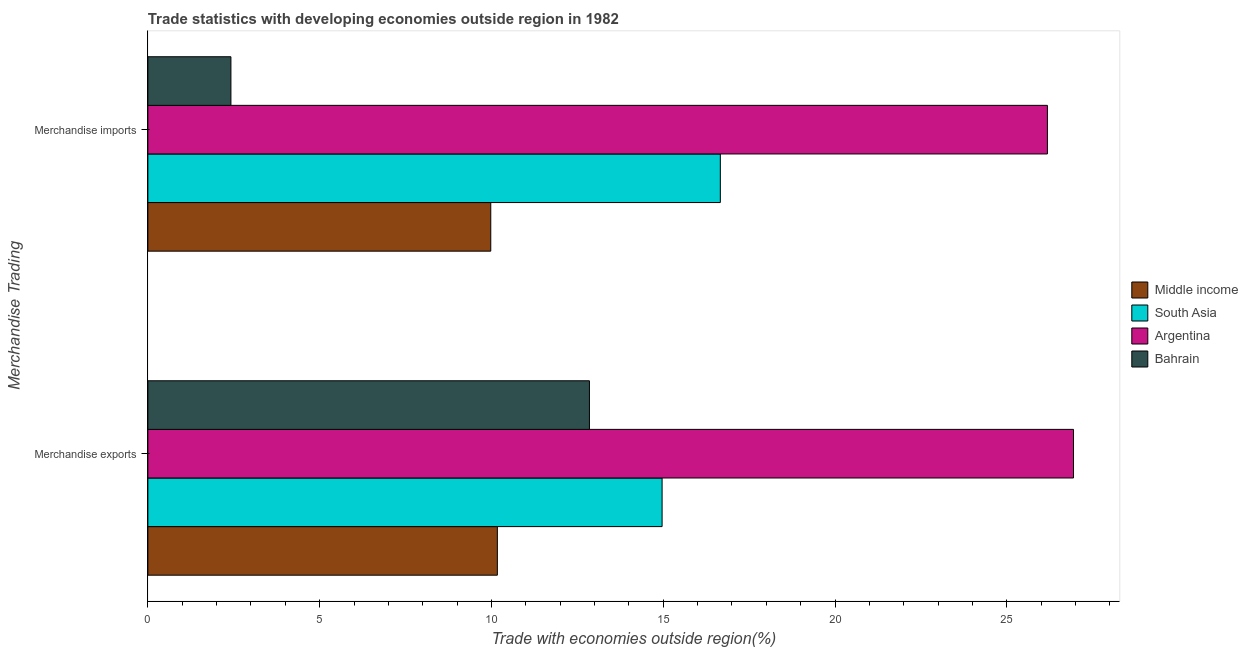How many different coloured bars are there?
Provide a short and direct response. 4. Are the number of bars per tick equal to the number of legend labels?
Your response must be concise. Yes. Are the number of bars on each tick of the Y-axis equal?
Offer a very short reply. Yes. How many bars are there on the 2nd tick from the top?
Provide a short and direct response. 4. What is the label of the 1st group of bars from the top?
Your answer should be compact. Merchandise imports. What is the merchandise exports in Bahrain?
Keep it short and to the point. 12.85. Across all countries, what is the maximum merchandise exports?
Provide a short and direct response. 26.94. Across all countries, what is the minimum merchandise imports?
Provide a succinct answer. 2.42. In which country was the merchandise imports minimum?
Your response must be concise. Bahrain. What is the total merchandise imports in the graph?
Offer a very short reply. 55.24. What is the difference between the merchandise imports in Bahrain and that in South Asia?
Your answer should be very brief. -14.24. What is the difference between the merchandise imports in Argentina and the merchandise exports in South Asia?
Keep it short and to the point. 11.22. What is the average merchandise exports per country?
Make the answer very short. 16.23. What is the difference between the merchandise imports and merchandise exports in Argentina?
Offer a very short reply. -0.76. What is the ratio of the merchandise imports in Argentina to that in Middle income?
Give a very brief answer. 2.62. Is the merchandise imports in Middle income less than that in Bahrain?
Keep it short and to the point. No. In how many countries, is the merchandise exports greater than the average merchandise exports taken over all countries?
Ensure brevity in your answer.  1. How many bars are there?
Your answer should be compact. 8. Are all the bars in the graph horizontal?
Give a very brief answer. Yes. How many countries are there in the graph?
Offer a terse response. 4. What is the difference between two consecutive major ticks on the X-axis?
Ensure brevity in your answer.  5. Does the graph contain any zero values?
Make the answer very short. No. Does the graph contain grids?
Offer a terse response. No. Where does the legend appear in the graph?
Your answer should be compact. Center right. How are the legend labels stacked?
Your answer should be very brief. Vertical. What is the title of the graph?
Offer a terse response. Trade statistics with developing economies outside region in 1982. Does "Mali" appear as one of the legend labels in the graph?
Offer a very short reply. No. What is the label or title of the X-axis?
Give a very brief answer. Trade with economies outside region(%). What is the label or title of the Y-axis?
Your response must be concise. Merchandise Trading. What is the Trade with economies outside region(%) of Middle income in Merchandise exports?
Provide a short and direct response. 10.17. What is the Trade with economies outside region(%) of South Asia in Merchandise exports?
Your answer should be very brief. 14.97. What is the Trade with economies outside region(%) of Argentina in Merchandise exports?
Give a very brief answer. 26.94. What is the Trade with economies outside region(%) in Bahrain in Merchandise exports?
Offer a terse response. 12.85. What is the Trade with economies outside region(%) in Middle income in Merchandise imports?
Provide a succinct answer. 9.98. What is the Trade with economies outside region(%) of South Asia in Merchandise imports?
Offer a terse response. 16.66. What is the Trade with economies outside region(%) in Argentina in Merchandise imports?
Provide a short and direct response. 26.18. What is the Trade with economies outside region(%) of Bahrain in Merchandise imports?
Your answer should be compact. 2.42. Across all Merchandise Trading, what is the maximum Trade with economies outside region(%) of Middle income?
Make the answer very short. 10.17. Across all Merchandise Trading, what is the maximum Trade with economies outside region(%) of South Asia?
Your response must be concise. 16.66. Across all Merchandise Trading, what is the maximum Trade with economies outside region(%) in Argentina?
Your answer should be compact. 26.94. Across all Merchandise Trading, what is the maximum Trade with economies outside region(%) of Bahrain?
Give a very brief answer. 12.85. Across all Merchandise Trading, what is the minimum Trade with economies outside region(%) in Middle income?
Ensure brevity in your answer.  9.98. Across all Merchandise Trading, what is the minimum Trade with economies outside region(%) of South Asia?
Your response must be concise. 14.97. Across all Merchandise Trading, what is the minimum Trade with economies outside region(%) of Argentina?
Offer a very short reply. 26.18. Across all Merchandise Trading, what is the minimum Trade with economies outside region(%) of Bahrain?
Your answer should be very brief. 2.42. What is the total Trade with economies outside region(%) in Middle income in the graph?
Offer a terse response. 20.15. What is the total Trade with economies outside region(%) in South Asia in the graph?
Provide a succinct answer. 31.63. What is the total Trade with economies outside region(%) of Argentina in the graph?
Your answer should be very brief. 53.12. What is the total Trade with economies outside region(%) of Bahrain in the graph?
Offer a terse response. 15.27. What is the difference between the Trade with economies outside region(%) of Middle income in Merchandise exports and that in Merchandise imports?
Give a very brief answer. 0.19. What is the difference between the Trade with economies outside region(%) in South Asia in Merchandise exports and that in Merchandise imports?
Ensure brevity in your answer.  -1.69. What is the difference between the Trade with economies outside region(%) in Argentina in Merchandise exports and that in Merchandise imports?
Give a very brief answer. 0.76. What is the difference between the Trade with economies outside region(%) of Bahrain in Merchandise exports and that in Merchandise imports?
Offer a very short reply. 10.43. What is the difference between the Trade with economies outside region(%) of Middle income in Merchandise exports and the Trade with economies outside region(%) of South Asia in Merchandise imports?
Offer a very short reply. -6.49. What is the difference between the Trade with economies outside region(%) in Middle income in Merchandise exports and the Trade with economies outside region(%) in Argentina in Merchandise imports?
Your response must be concise. -16.01. What is the difference between the Trade with economies outside region(%) in Middle income in Merchandise exports and the Trade with economies outside region(%) in Bahrain in Merchandise imports?
Your answer should be very brief. 7.75. What is the difference between the Trade with economies outside region(%) in South Asia in Merchandise exports and the Trade with economies outside region(%) in Argentina in Merchandise imports?
Offer a very short reply. -11.22. What is the difference between the Trade with economies outside region(%) in South Asia in Merchandise exports and the Trade with economies outside region(%) in Bahrain in Merchandise imports?
Your response must be concise. 12.55. What is the difference between the Trade with economies outside region(%) in Argentina in Merchandise exports and the Trade with economies outside region(%) in Bahrain in Merchandise imports?
Keep it short and to the point. 24.52. What is the average Trade with economies outside region(%) in Middle income per Merchandise Trading?
Your answer should be compact. 10.08. What is the average Trade with economies outside region(%) in South Asia per Merchandise Trading?
Offer a terse response. 15.81. What is the average Trade with economies outside region(%) in Argentina per Merchandise Trading?
Ensure brevity in your answer.  26.56. What is the average Trade with economies outside region(%) in Bahrain per Merchandise Trading?
Keep it short and to the point. 7.63. What is the difference between the Trade with economies outside region(%) of Middle income and Trade with economies outside region(%) of South Asia in Merchandise exports?
Offer a terse response. -4.8. What is the difference between the Trade with economies outside region(%) of Middle income and Trade with economies outside region(%) of Argentina in Merchandise exports?
Make the answer very short. -16.77. What is the difference between the Trade with economies outside region(%) in Middle income and Trade with economies outside region(%) in Bahrain in Merchandise exports?
Your response must be concise. -2.68. What is the difference between the Trade with economies outside region(%) of South Asia and Trade with economies outside region(%) of Argentina in Merchandise exports?
Provide a succinct answer. -11.97. What is the difference between the Trade with economies outside region(%) in South Asia and Trade with economies outside region(%) in Bahrain in Merchandise exports?
Provide a short and direct response. 2.12. What is the difference between the Trade with economies outside region(%) in Argentina and Trade with economies outside region(%) in Bahrain in Merchandise exports?
Keep it short and to the point. 14.09. What is the difference between the Trade with economies outside region(%) in Middle income and Trade with economies outside region(%) in South Asia in Merchandise imports?
Offer a very short reply. -6.68. What is the difference between the Trade with economies outside region(%) of Middle income and Trade with economies outside region(%) of Argentina in Merchandise imports?
Your response must be concise. -16.2. What is the difference between the Trade with economies outside region(%) in Middle income and Trade with economies outside region(%) in Bahrain in Merchandise imports?
Your answer should be very brief. 7.56. What is the difference between the Trade with economies outside region(%) of South Asia and Trade with economies outside region(%) of Argentina in Merchandise imports?
Your response must be concise. -9.52. What is the difference between the Trade with economies outside region(%) in South Asia and Trade with economies outside region(%) in Bahrain in Merchandise imports?
Provide a succinct answer. 14.24. What is the difference between the Trade with economies outside region(%) of Argentina and Trade with economies outside region(%) of Bahrain in Merchandise imports?
Keep it short and to the point. 23.77. What is the ratio of the Trade with economies outside region(%) in Middle income in Merchandise exports to that in Merchandise imports?
Make the answer very short. 1.02. What is the ratio of the Trade with economies outside region(%) of South Asia in Merchandise exports to that in Merchandise imports?
Provide a short and direct response. 0.9. What is the ratio of the Trade with economies outside region(%) of Bahrain in Merchandise exports to that in Merchandise imports?
Provide a succinct answer. 5.32. What is the difference between the highest and the second highest Trade with economies outside region(%) in Middle income?
Give a very brief answer. 0.19. What is the difference between the highest and the second highest Trade with economies outside region(%) of South Asia?
Make the answer very short. 1.69. What is the difference between the highest and the second highest Trade with economies outside region(%) in Argentina?
Give a very brief answer. 0.76. What is the difference between the highest and the second highest Trade with economies outside region(%) of Bahrain?
Keep it short and to the point. 10.43. What is the difference between the highest and the lowest Trade with economies outside region(%) of Middle income?
Offer a very short reply. 0.19. What is the difference between the highest and the lowest Trade with economies outside region(%) in South Asia?
Make the answer very short. 1.69. What is the difference between the highest and the lowest Trade with economies outside region(%) of Argentina?
Your answer should be compact. 0.76. What is the difference between the highest and the lowest Trade with economies outside region(%) in Bahrain?
Your answer should be very brief. 10.43. 